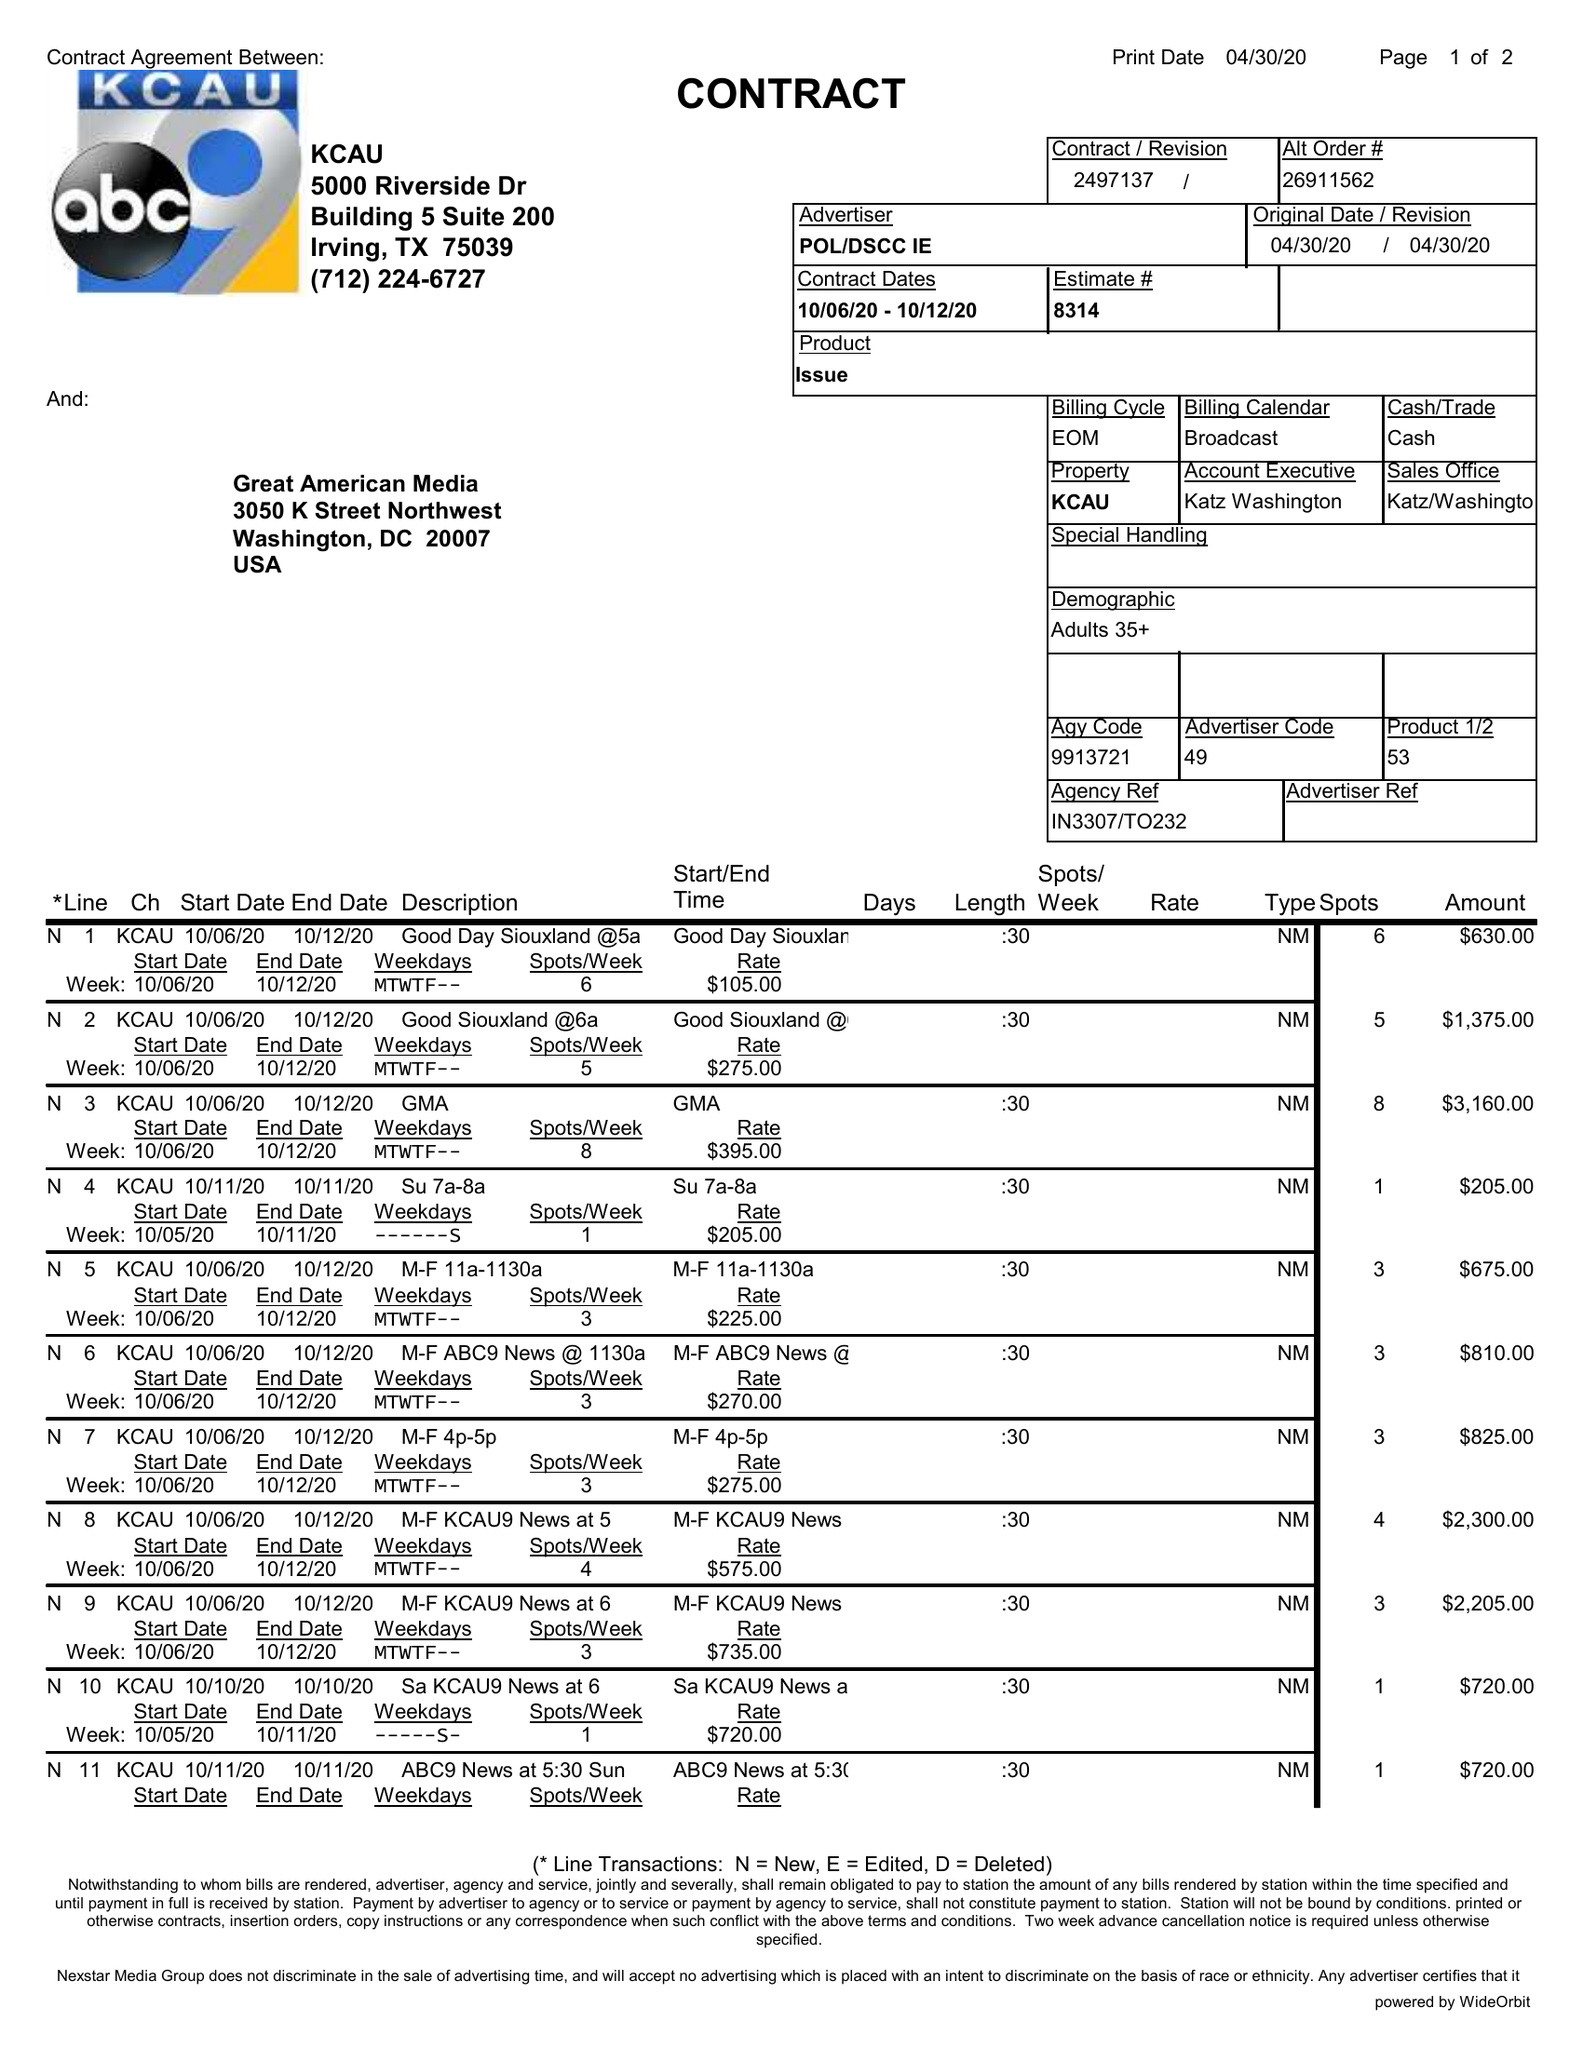What is the value for the gross_amount?
Answer the question using a single word or phrase. 29585.00 